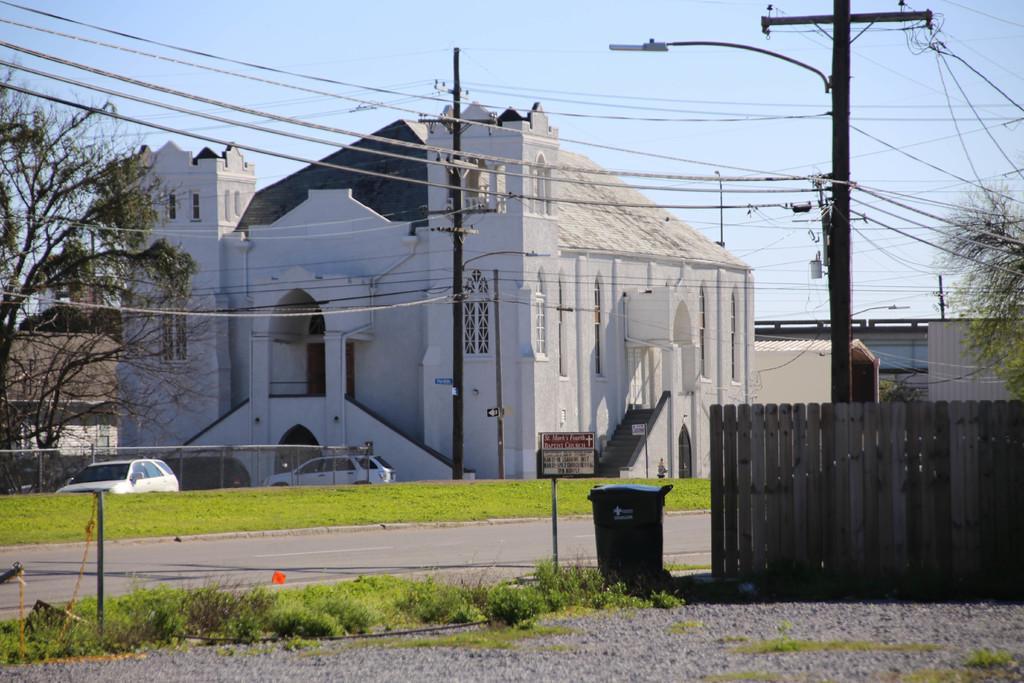Describe this image in one or two sentences. In this image there is a dustbin,grass, plants, vehicles, buildings, poles, lights, boards, fence, trees, and in the background there is sky. 